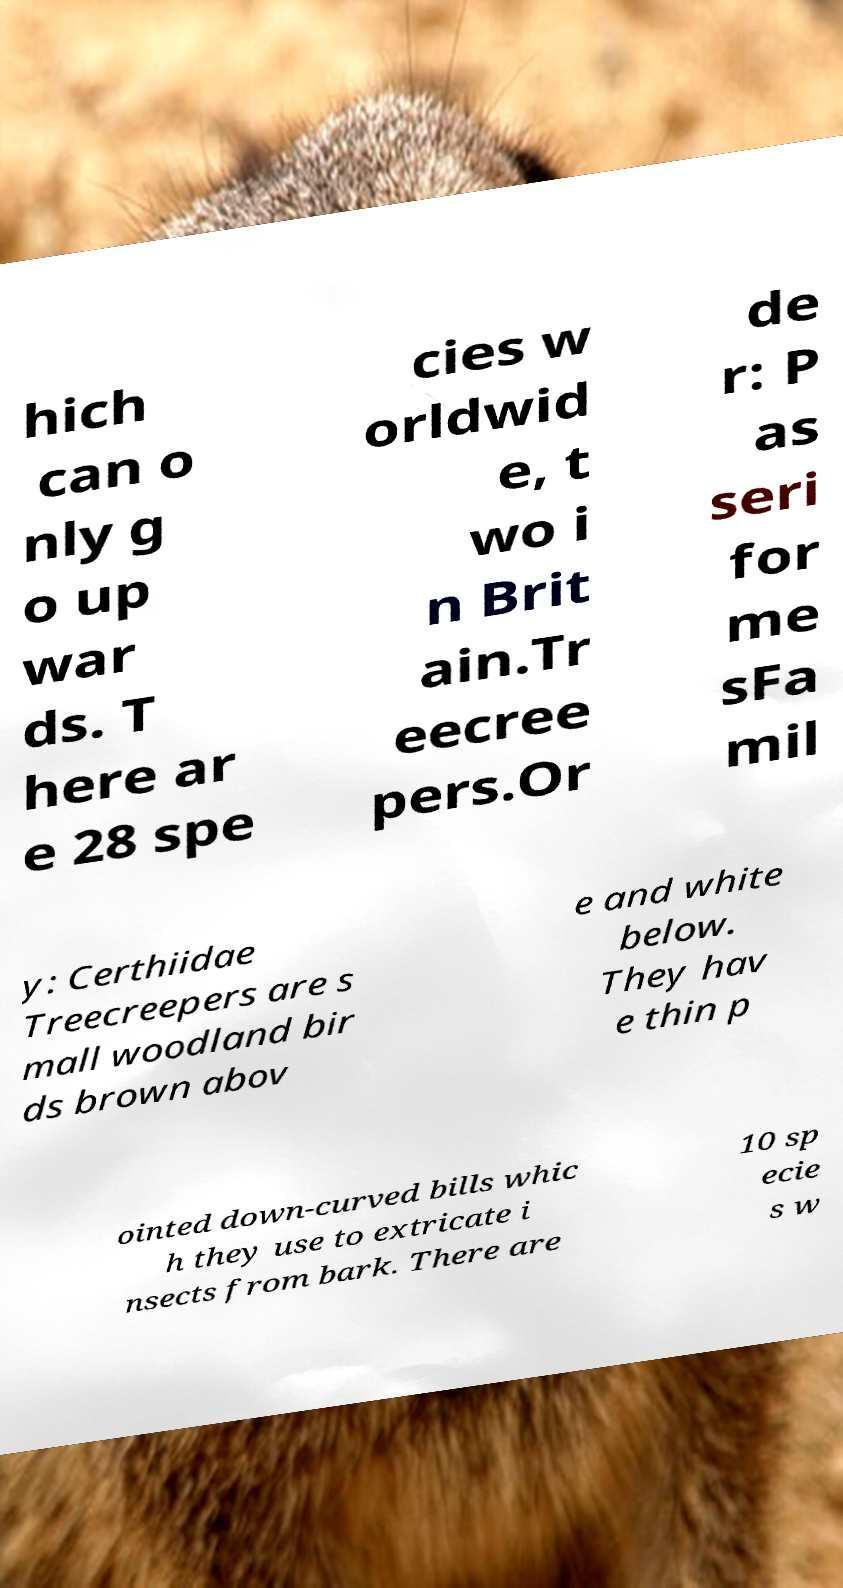Can you read and provide the text displayed in the image?This photo seems to have some interesting text. Can you extract and type it out for me? hich can o nly g o up war ds. T here ar e 28 spe cies w orldwid e, t wo i n Brit ain.Tr eecree pers.Or de r: P as seri for me sFa mil y: Certhiidae Treecreepers are s mall woodland bir ds brown abov e and white below. They hav e thin p ointed down-curved bills whic h they use to extricate i nsects from bark. There are 10 sp ecie s w 